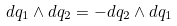Convert formula to latex. <formula><loc_0><loc_0><loc_500><loc_500>d q _ { 1 } \wedge d q _ { 2 } = - d q _ { 2 } \wedge d q _ { 1 }</formula> 